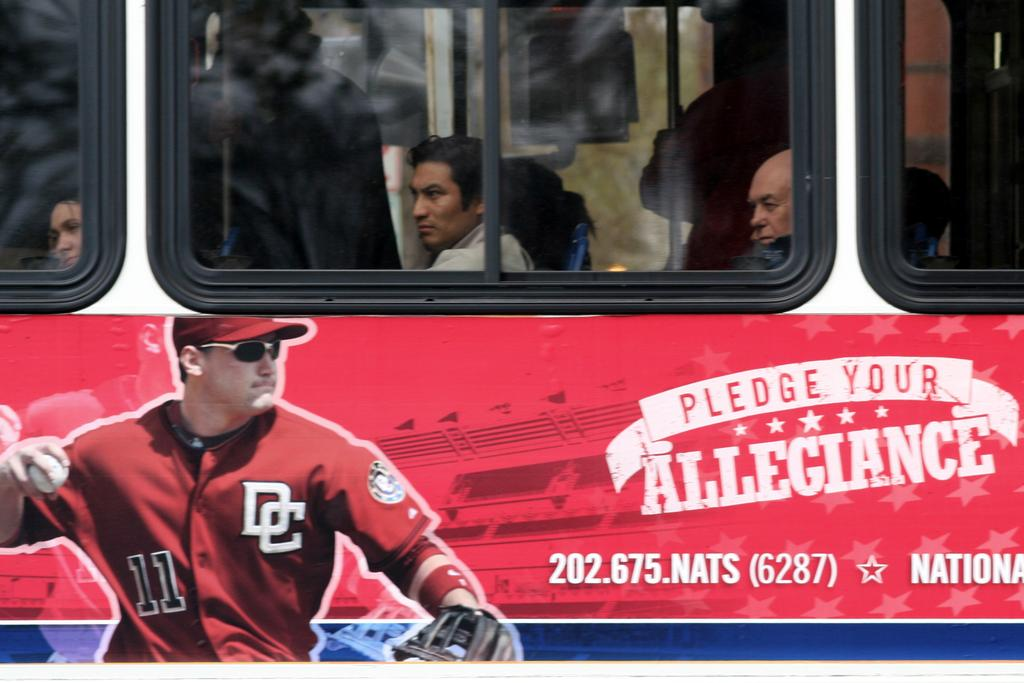<image>
Give a short and clear explanation of the subsequent image. A "Pledge your allegiance" advertisement on the side of a bus 